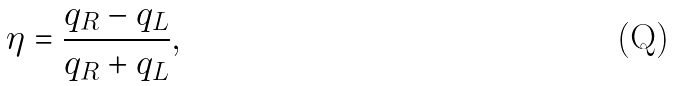<formula> <loc_0><loc_0><loc_500><loc_500>\eta = \frac { q _ { R } - q _ { L } } { q _ { R } + q _ { L } } ,</formula> 